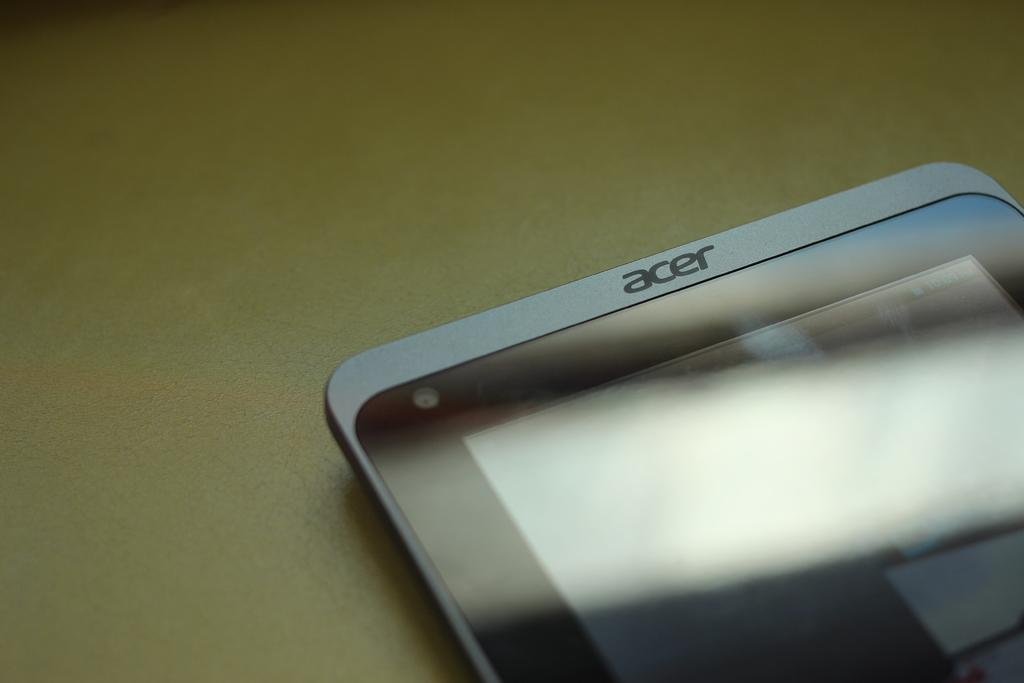<image>
Create a compact narrative representing the image presented. An aesthetic advertisement image of an acer phone. 